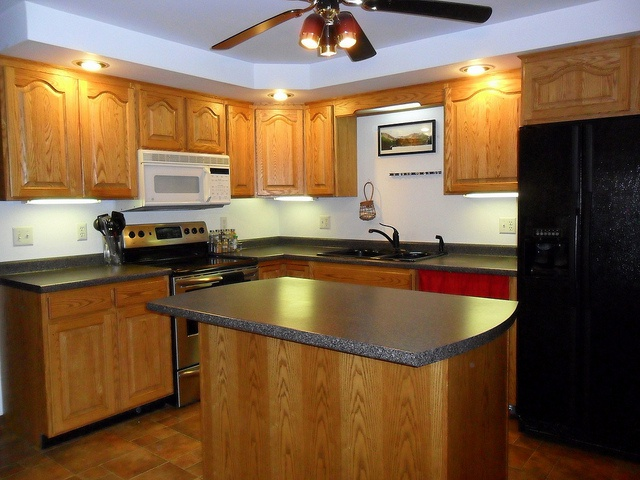Describe the objects in this image and their specific colors. I can see dining table in gray, brown, and maroon tones, refrigerator in gray, black, and maroon tones, oven in gray, black, maroon, and olive tones, microwave in gray, darkgray, and tan tones, and sink in gray and black tones in this image. 